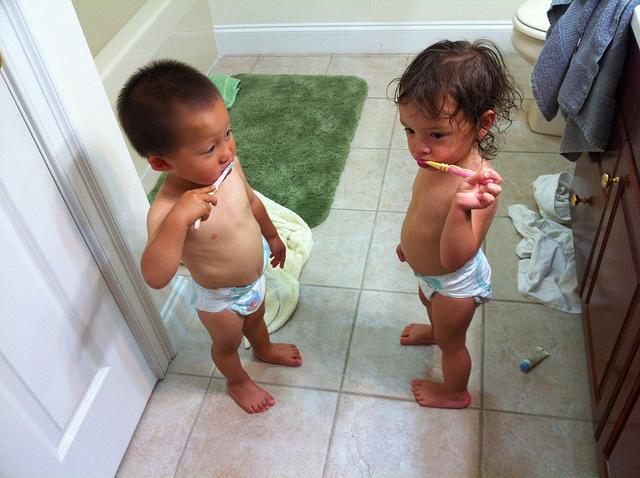How is the kid on the right brushing his teeth differently from the kid on the left?
Choose the correct response and explain in the format: 'Answer: answer
Rationale: rationale.'
Options: Electric, different toothpaste, crying, lefthanded. Answer: lefthanded.
Rationale: One child is brushing with their right hand and the other is not. 